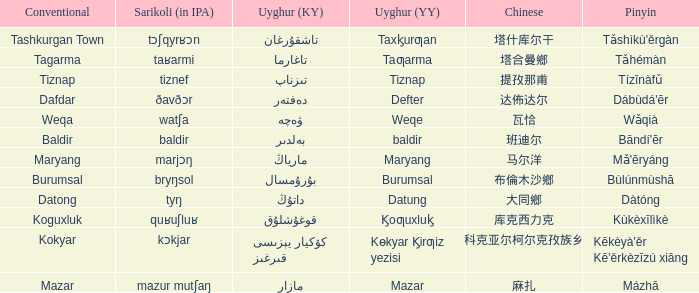Name the conventional for تاغارما Tagarma. 